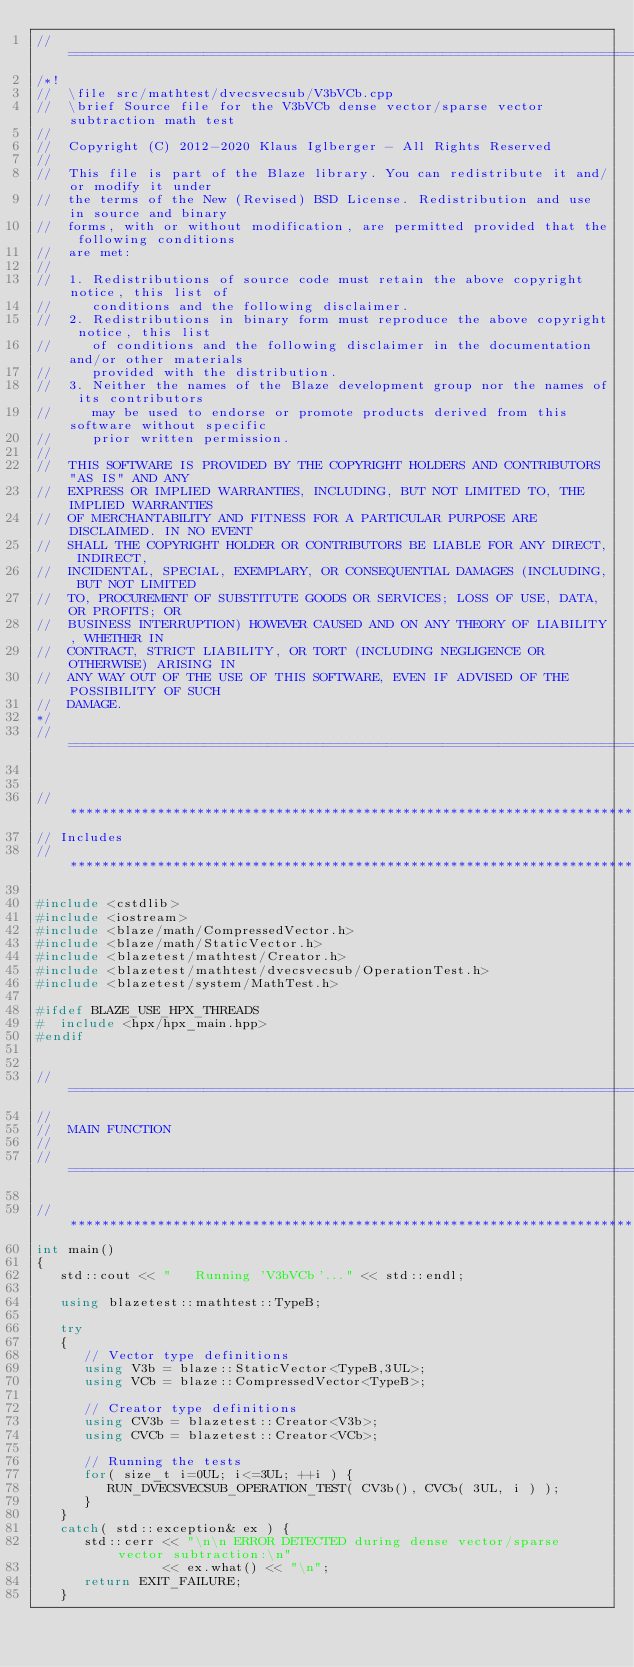Convert code to text. <code><loc_0><loc_0><loc_500><loc_500><_C++_>//=================================================================================================
/*!
//  \file src/mathtest/dvecsvecsub/V3bVCb.cpp
//  \brief Source file for the V3bVCb dense vector/sparse vector subtraction math test
//
//  Copyright (C) 2012-2020 Klaus Iglberger - All Rights Reserved
//
//  This file is part of the Blaze library. You can redistribute it and/or modify it under
//  the terms of the New (Revised) BSD License. Redistribution and use in source and binary
//  forms, with or without modification, are permitted provided that the following conditions
//  are met:
//
//  1. Redistributions of source code must retain the above copyright notice, this list of
//     conditions and the following disclaimer.
//  2. Redistributions in binary form must reproduce the above copyright notice, this list
//     of conditions and the following disclaimer in the documentation and/or other materials
//     provided with the distribution.
//  3. Neither the names of the Blaze development group nor the names of its contributors
//     may be used to endorse or promote products derived from this software without specific
//     prior written permission.
//
//  THIS SOFTWARE IS PROVIDED BY THE COPYRIGHT HOLDERS AND CONTRIBUTORS "AS IS" AND ANY
//  EXPRESS OR IMPLIED WARRANTIES, INCLUDING, BUT NOT LIMITED TO, THE IMPLIED WARRANTIES
//  OF MERCHANTABILITY AND FITNESS FOR A PARTICULAR PURPOSE ARE DISCLAIMED. IN NO EVENT
//  SHALL THE COPYRIGHT HOLDER OR CONTRIBUTORS BE LIABLE FOR ANY DIRECT, INDIRECT,
//  INCIDENTAL, SPECIAL, EXEMPLARY, OR CONSEQUENTIAL DAMAGES (INCLUDING, BUT NOT LIMITED
//  TO, PROCUREMENT OF SUBSTITUTE GOODS OR SERVICES; LOSS OF USE, DATA, OR PROFITS; OR
//  BUSINESS INTERRUPTION) HOWEVER CAUSED AND ON ANY THEORY OF LIABILITY, WHETHER IN
//  CONTRACT, STRICT LIABILITY, OR TORT (INCLUDING NEGLIGENCE OR OTHERWISE) ARISING IN
//  ANY WAY OUT OF THE USE OF THIS SOFTWARE, EVEN IF ADVISED OF THE POSSIBILITY OF SUCH
//  DAMAGE.
*/
//=================================================================================================


//*************************************************************************************************
// Includes
//*************************************************************************************************

#include <cstdlib>
#include <iostream>
#include <blaze/math/CompressedVector.h>
#include <blaze/math/StaticVector.h>
#include <blazetest/mathtest/Creator.h>
#include <blazetest/mathtest/dvecsvecsub/OperationTest.h>
#include <blazetest/system/MathTest.h>

#ifdef BLAZE_USE_HPX_THREADS
#  include <hpx/hpx_main.hpp>
#endif


//=================================================================================================
//
//  MAIN FUNCTION
//
//=================================================================================================

//*************************************************************************************************
int main()
{
   std::cout << "   Running 'V3bVCb'..." << std::endl;

   using blazetest::mathtest::TypeB;

   try
   {
      // Vector type definitions
      using V3b = blaze::StaticVector<TypeB,3UL>;
      using VCb = blaze::CompressedVector<TypeB>;

      // Creator type definitions
      using CV3b = blazetest::Creator<V3b>;
      using CVCb = blazetest::Creator<VCb>;

      // Running the tests
      for( size_t i=0UL; i<=3UL; ++i ) {
         RUN_DVECSVECSUB_OPERATION_TEST( CV3b(), CVCb( 3UL, i ) );
      }
   }
   catch( std::exception& ex ) {
      std::cerr << "\n\n ERROR DETECTED during dense vector/sparse vector subtraction:\n"
                << ex.what() << "\n";
      return EXIT_FAILURE;
   }
</code> 